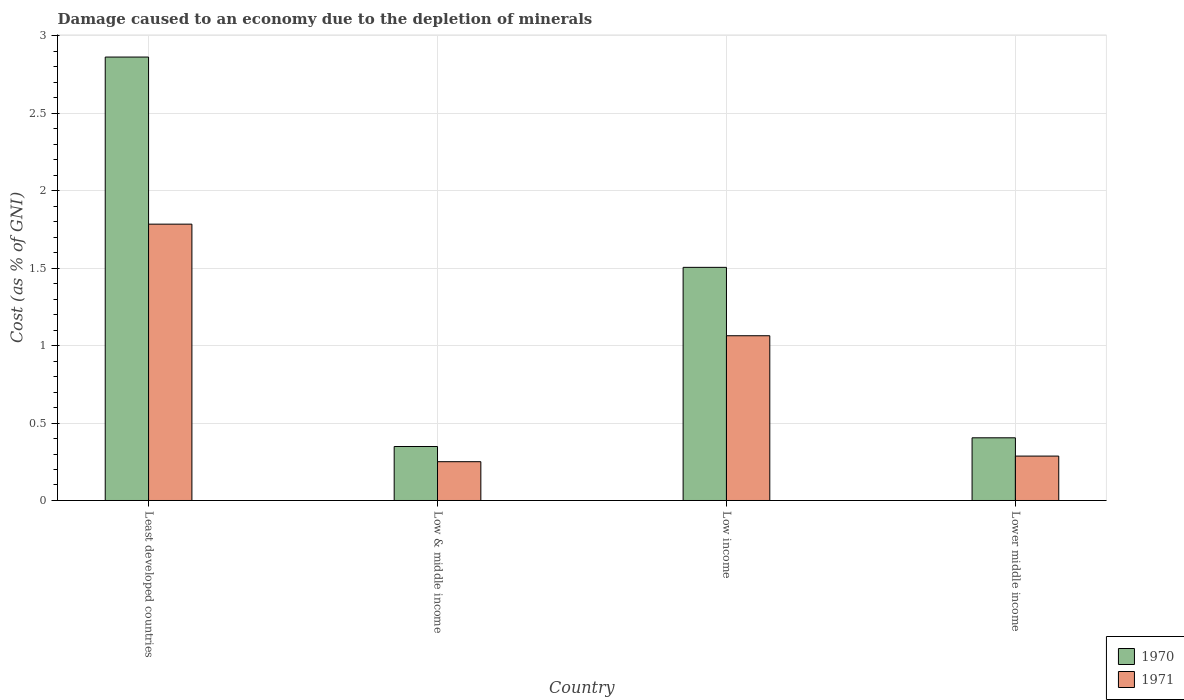How many different coloured bars are there?
Give a very brief answer. 2. How many bars are there on the 1st tick from the left?
Give a very brief answer. 2. What is the label of the 4th group of bars from the left?
Offer a very short reply. Lower middle income. What is the cost of damage caused due to the depletion of minerals in 1970 in Low income?
Offer a very short reply. 1.51. Across all countries, what is the maximum cost of damage caused due to the depletion of minerals in 1971?
Your answer should be very brief. 1.78. Across all countries, what is the minimum cost of damage caused due to the depletion of minerals in 1971?
Ensure brevity in your answer.  0.25. In which country was the cost of damage caused due to the depletion of minerals in 1971 maximum?
Provide a succinct answer. Least developed countries. What is the total cost of damage caused due to the depletion of minerals in 1970 in the graph?
Provide a succinct answer. 5.12. What is the difference between the cost of damage caused due to the depletion of minerals in 1970 in Low income and that in Lower middle income?
Offer a terse response. 1.1. What is the difference between the cost of damage caused due to the depletion of minerals in 1970 in Low income and the cost of damage caused due to the depletion of minerals in 1971 in Low & middle income?
Offer a terse response. 1.25. What is the average cost of damage caused due to the depletion of minerals in 1970 per country?
Ensure brevity in your answer.  1.28. What is the difference between the cost of damage caused due to the depletion of minerals of/in 1971 and cost of damage caused due to the depletion of minerals of/in 1970 in Low income?
Your response must be concise. -0.44. What is the ratio of the cost of damage caused due to the depletion of minerals in 1970 in Least developed countries to that in Low & middle income?
Your answer should be compact. 8.22. Is the difference between the cost of damage caused due to the depletion of minerals in 1971 in Least developed countries and Low & middle income greater than the difference between the cost of damage caused due to the depletion of minerals in 1970 in Least developed countries and Low & middle income?
Give a very brief answer. No. What is the difference between the highest and the second highest cost of damage caused due to the depletion of minerals in 1971?
Keep it short and to the point. -1.5. What is the difference between the highest and the lowest cost of damage caused due to the depletion of minerals in 1970?
Offer a terse response. 2.52. In how many countries, is the cost of damage caused due to the depletion of minerals in 1971 greater than the average cost of damage caused due to the depletion of minerals in 1971 taken over all countries?
Your response must be concise. 2. What does the 1st bar from the left in Low income represents?
Ensure brevity in your answer.  1970. What does the 2nd bar from the right in Lower middle income represents?
Your answer should be very brief. 1970. How many bars are there?
Your answer should be compact. 8. Are all the bars in the graph horizontal?
Ensure brevity in your answer.  No. Are the values on the major ticks of Y-axis written in scientific E-notation?
Keep it short and to the point. No. Does the graph contain any zero values?
Your response must be concise. No. How many legend labels are there?
Your answer should be very brief. 2. How are the legend labels stacked?
Provide a succinct answer. Vertical. What is the title of the graph?
Give a very brief answer. Damage caused to an economy due to the depletion of minerals. What is the label or title of the Y-axis?
Provide a short and direct response. Cost (as % of GNI). What is the Cost (as % of GNI) of 1970 in Least developed countries?
Offer a very short reply. 2.86. What is the Cost (as % of GNI) in 1971 in Least developed countries?
Provide a succinct answer. 1.78. What is the Cost (as % of GNI) in 1970 in Low & middle income?
Make the answer very short. 0.35. What is the Cost (as % of GNI) of 1971 in Low & middle income?
Your answer should be very brief. 0.25. What is the Cost (as % of GNI) in 1970 in Low income?
Provide a short and direct response. 1.51. What is the Cost (as % of GNI) in 1971 in Low income?
Make the answer very short. 1.06. What is the Cost (as % of GNI) in 1970 in Lower middle income?
Offer a very short reply. 0.4. What is the Cost (as % of GNI) of 1971 in Lower middle income?
Keep it short and to the point. 0.29. Across all countries, what is the maximum Cost (as % of GNI) of 1970?
Offer a very short reply. 2.86. Across all countries, what is the maximum Cost (as % of GNI) of 1971?
Ensure brevity in your answer.  1.78. Across all countries, what is the minimum Cost (as % of GNI) of 1970?
Offer a very short reply. 0.35. Across all countries, what is the minimum Cost (as % of GNI) of 1971?
Offer a very short reply. 0.25. What is the total Cost (as % of GNI) of 1970 in the graph?
Ensure brevity in your answer.  5.12. What is the total Cost (as % of GNI) in 1971 in the graph?
Your answer should be compact. 3.39. What is the difference between the Cost (as % of GNI) in 1970 in Least developed countries and that in Low & middle income?
Provide a short and direct response. 2.52. What is the difference between the Cost (as % of GNI) in 1971 in Least developed countries and that in Low & middle income?
Your response must be concise. 1.53. What is the difference between the Cost (as % of GNI) of 1970 in Least developed countries and that in Low income?
Keep it short and to the point. 1.36. What is the difference between the Cost (as % of GNI) in 1971 in Least developed countries and that in Low income?
Your answer should be very brief. 0.72. What is the difference between the Cost (as % of GNI) in 1970 in Least developed countries and that in Lower middle income?
Keep it short and to the point. 2.46. What is the difference between the Cost (as % of GNI) of 1971 in Least developed countries and that in Lower middle income?
Make the answer very short. 1.5. What is the difference between the Cost (as % of GNI) of 1970 in Low & middle income and that in Low income?
Your answer should be compact. -1.16. What is the difference between the Cost (as % of GNI) of 1971 in Low & middle income and that in Low income?
Offer a very short reply. -0.81. What is the difference between the Cost (as % of GNI) in 1970 in Low & middle income and that in Lower middle income?
Make the answer very short. -0.06. What is the difference between the Cost (as % of GNI) of 1971 in Low & middle income and that in Lower middle income?
Your answer should be very brief. -0.04. What is the difference between the Cost (as % of GNI) in 1970 in Low income and that in Lower middle income?
Ensure brevity in your answer.  1.1. What is the difference between the Cost (as % of GNI) of 1971 in Low income and that in Lower middle income?
Offer a very short reply. 0.78. What is the difference between the Cost (as % of GNI) in 1970 in Least developed countries and the Cost (as % of GNI) in 1971 in Low & middle income?
Provide a succinct answer. 2.61. What is the difference between the Cost (as % of GNI) of 1970 in Least developed countries and the Cost (as % of GNI) of 1971 in Low income?
Keep it short and to the point. 1.8. What is the difference between the Cost (as % of GNI) in 1970 in Least developed countries and the Cost (as % of GNI) in 1971 in Lower middle income?
Keep it short and to the point. 2.58. What is the difference between the Cost (as % of GNI) in 1970 in Low & middle income and the Cost (as % of GNI) in 1971 in Low income?
Your response must be concise. -0.72. What is the difference between the Cost (as % of GNI) in 1970 in Low & middle income and the Cost (as % of GNI) in 1971 in Lower middle income?
Make the answer very short. 0.06. What is the difference between the Cost (as % of GNI) of 1970 in Low income and the Cost (as % of GNI) of 1971 in Lower middle income?
Provide a short and direct response. 1.22. What is the average Cost (as % of GNI) of 1970 per country?
Offer a very short reply. 1.28. What is the average Cost (as % of GNI) in 1971 per country?
Give a very brief answer. 0.85. What is the difference between the Cost (as % of GNI) of 1970 and Cost (as % of GNI) of 1971 in Least developed countries?
Provide a succinct answer. 1.08. What is the difference between the Cost (as % of GNI) of 1970 and Cost (as % of GNI) of 1971 in Low & middle income?
Ensure brevity in your answer.  0.1. What is the difference between the Cost (as % of GNI) of 1970 and Cost (as % of GNI) of 1971 in Low income?
Provide a short and direct response. 0.44. What is the difference between the Cost (as % of GNI) of 1970 and Cost (as % of GNI) of 1971 in Lower middle income?
Your answer should be compact. 0.12. What is the ratio of the Cost (as % of GNI) in 1970 in Least developed countries to that in Low & middle income?
Give a very brief answer. 8.22. What is the ratio of the Cost (as % of GNI) of 1971 in Least developed countries to that in Low & middle income?
Ensure brevity in your answer.  7.12. What is the ratio of the Cost (as % of GNI) in 1970 in Least developed countries to that in Low income?
Your response must be concise. 1.9. What is the ratio of the Cost (as % of GNI) in 1971 in Least developed countries to that in Low income?
Offer a very short reply. 1.68. What is the ratio of the Cost (as % of GNI) in 1970 in Least developed countries to that in Lower middle income?
Your answer should be very brief. 7.07. What is the ratio of the Cost (as % of GNI) of 1971 in Least developed countries to that in Lower middle income?
Provide a short and direct response. 6.22. What is the ratio of the Cost (as % of GNI) in 1970 in Low & middle income to that in Low income?
Offer a very short reply. 0.23. What is the ratio of the Cost (as % of GNI) of 1971 in Low & middle income to that in Low income?
Your response must be concise. 0.24. What is the ratio of the Cost (as % of GNI) of 1970 in Low & middle income to that in Lower middle income?
Your answer should be very brief. 0.86. What is the ratio of the Cost (as % of GNI) in 1971 in Low & middle income to that in Lower middle income?
Ensure brevity in your answer.  0.87. What is the ratio of the Cost (as % of GNI) of 1970 in Low income to that in Lower middle income?
Keep it short and to the point. 3.72. What is the ratio of the Cost (as % of GNI) in 1971 in Low income to that in Lower middle income?
Give a very brief answer. 3.71. What is the difference between the highest and the second highest Cost (as % of GNI) in 1970?
Keep it short and to the point. 1.36. What is the difference between the highest and the second highest Cost (as % of GNI) in 1971?
Provide a short and direct response. 0.72. What is the difference between the highest and the lowest Cost (as % of GNI) in 1970?
Give a very brief answer. 2.52. What is the difference between the highest and the lowest Cost (as % of GNI) of 1971?
Offer a very short reply. 1.53. 